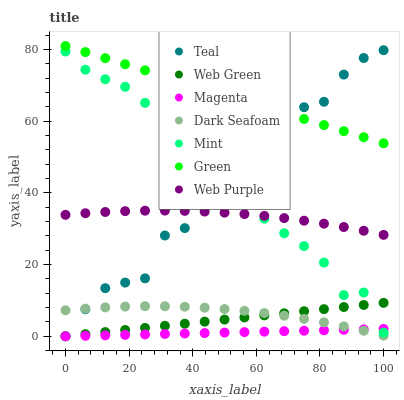Does Magenta have the minimum area under the curve?
Answer yes or no. Yes. Does Green have the maximum area under the curve?
Answer yes or no. Yes. Does Web Green have the minimum area under the curve?
Answer yes or no. No. Does Web Green have the maximum area under the curve?
Answer yes or no. No. Is Magenta the smoothest?
Answer yes or no. Yes. Is Teal the roughest?
Answer yes or no. Yes. Is Web Green the smoothest?
Answer yes or no. No. Is Web Green the roughest?
Answer yes or no. No. Does Web Green have the lowest value?
Answer yes or no. Yes. Does Dark Seafoam have the lowest value?
Answer yes or no. No. Does Green have the highest value?
Answer yes or no. Yes. Does Web Green have the highest value?
Answer yes or no. No. Is Magenta less than Web Purple?
Answer yes or no. Yes. Is Green greater than Mint?
Answer yes or no. Yes. Does Web Green intersect Magenta?
Answer yes or no. Yes. Is Web Green less than Magenta?
Answer yes or no. No. Is Web Green greater than Magenta?
Answer yes or no. No. Does Magenta intersect Web Purple?
Answer yes or no. No. 